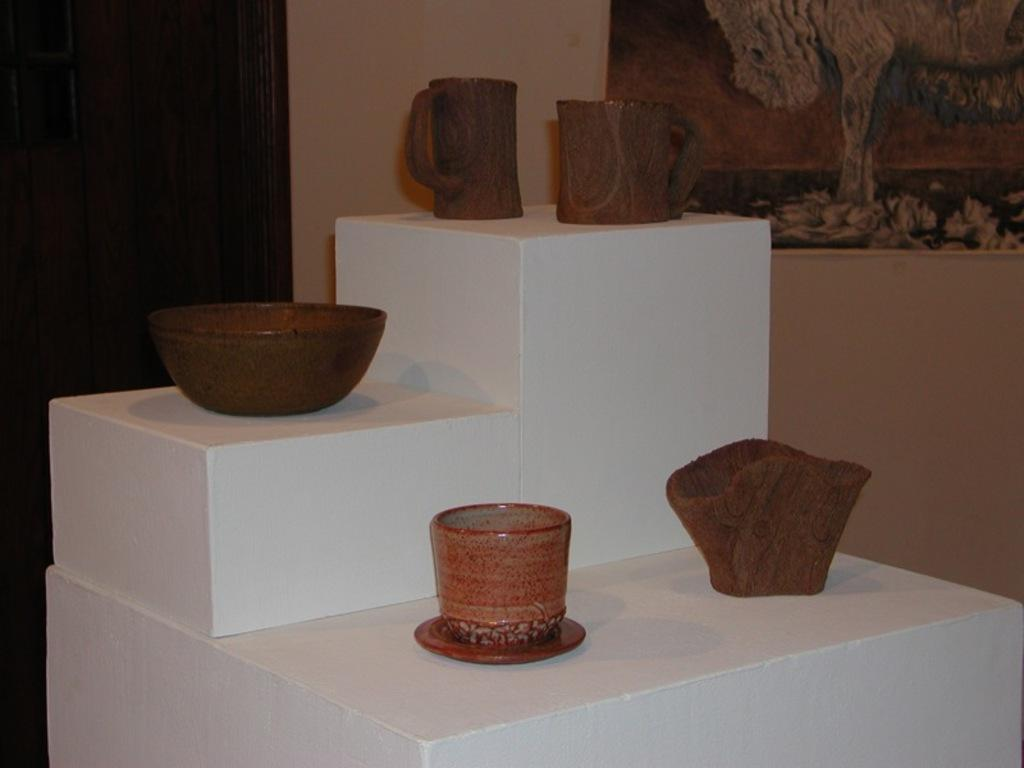What can be seen in the image related to historical or cultural items? Artifacts are displayed in the image. What architectural feature is visible at the back of the image? There is a door at the back side of the image. What is beside the door in the image? There is a wall beside the door. What is attached to the wall in the image? A poster is attached to the wall. What language is spoken by the people in the image? There are no people visible in the image. 